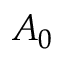<formula> <loc_0><loc_0><loc_500><loc_500>A _ { 0 }</formula> 